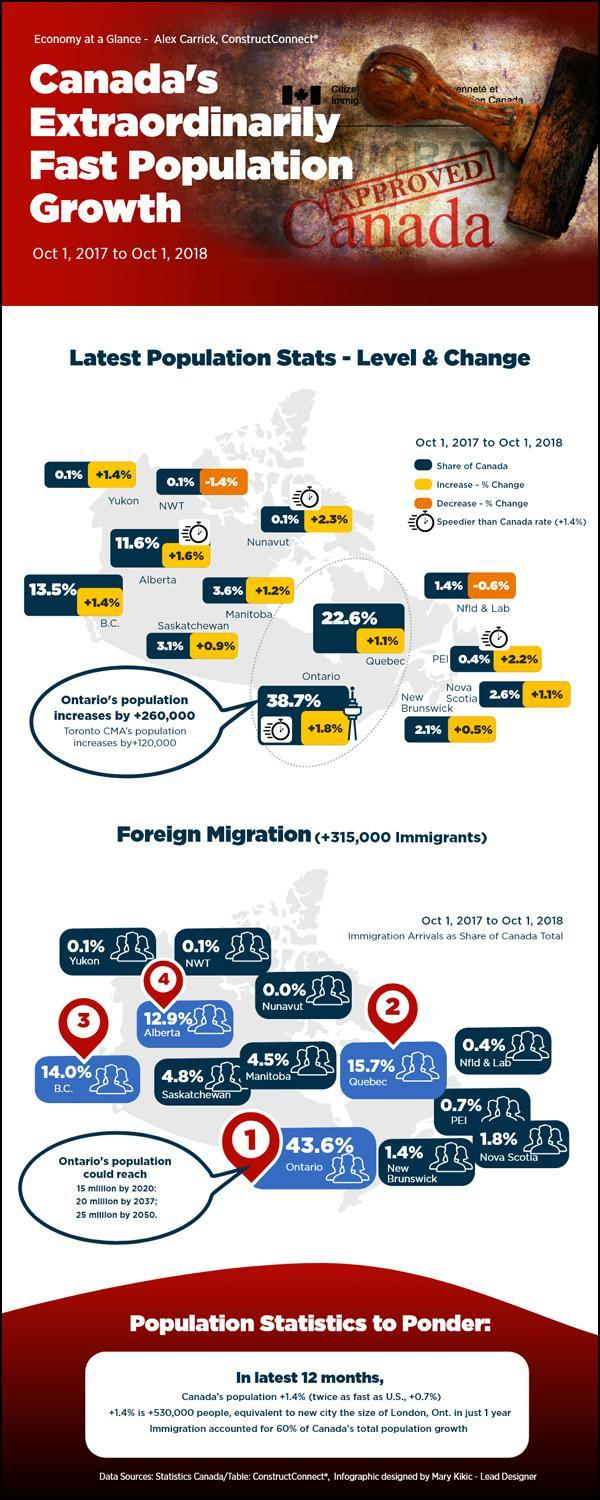How much is the rate of increase in population in Alberta?
Answer the question with a short phrase. +1.6% What percentage of the population of Nova Scotia is Foreign? 1.8 Which place in Canada has the second-highest increase in population growth? PEI What percentage of the population of Ontario is Foreign? 43.6 What percentage of the Canadian population is in Manitoba? 3.6% Which place in Canada contributes the highest to the total population of Canada? Ontario Which place in Canada has the highest increase in population growth rate? Nunavut What percentage of the Canadian population is in Alberta? 11.6% Which place in Canada contributes the second-highest to the total population of Canada? Quebec What percentage of the Canadian population is in Quebec? 22.6% 